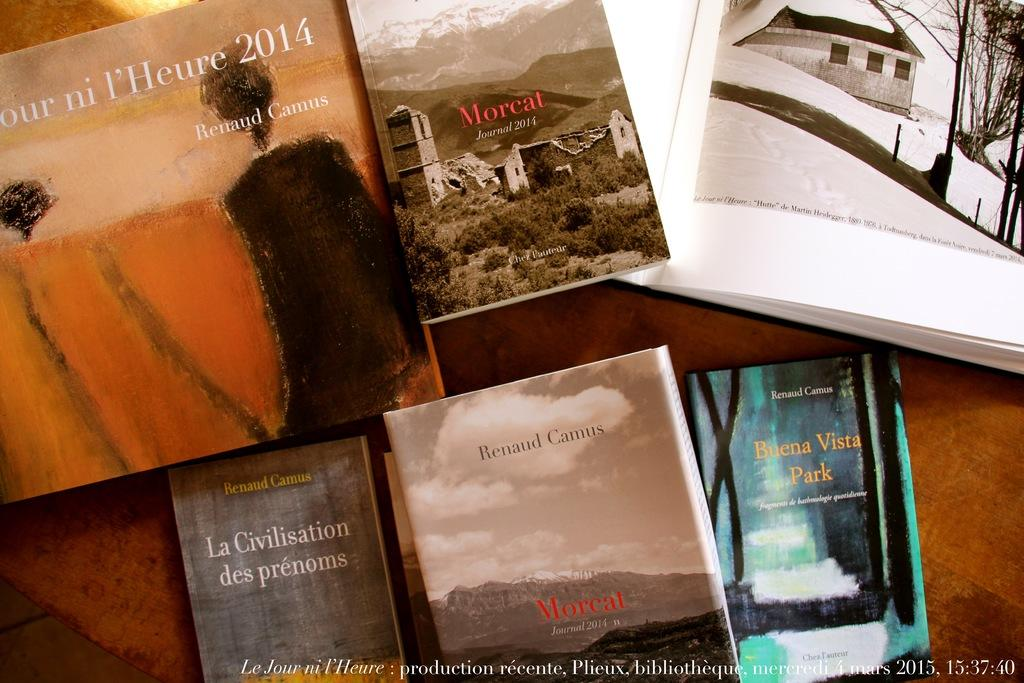<image>
Give a short and clear explanation of the subsequent image. Various scenes are displayed with one in yellow with the year 2014. 